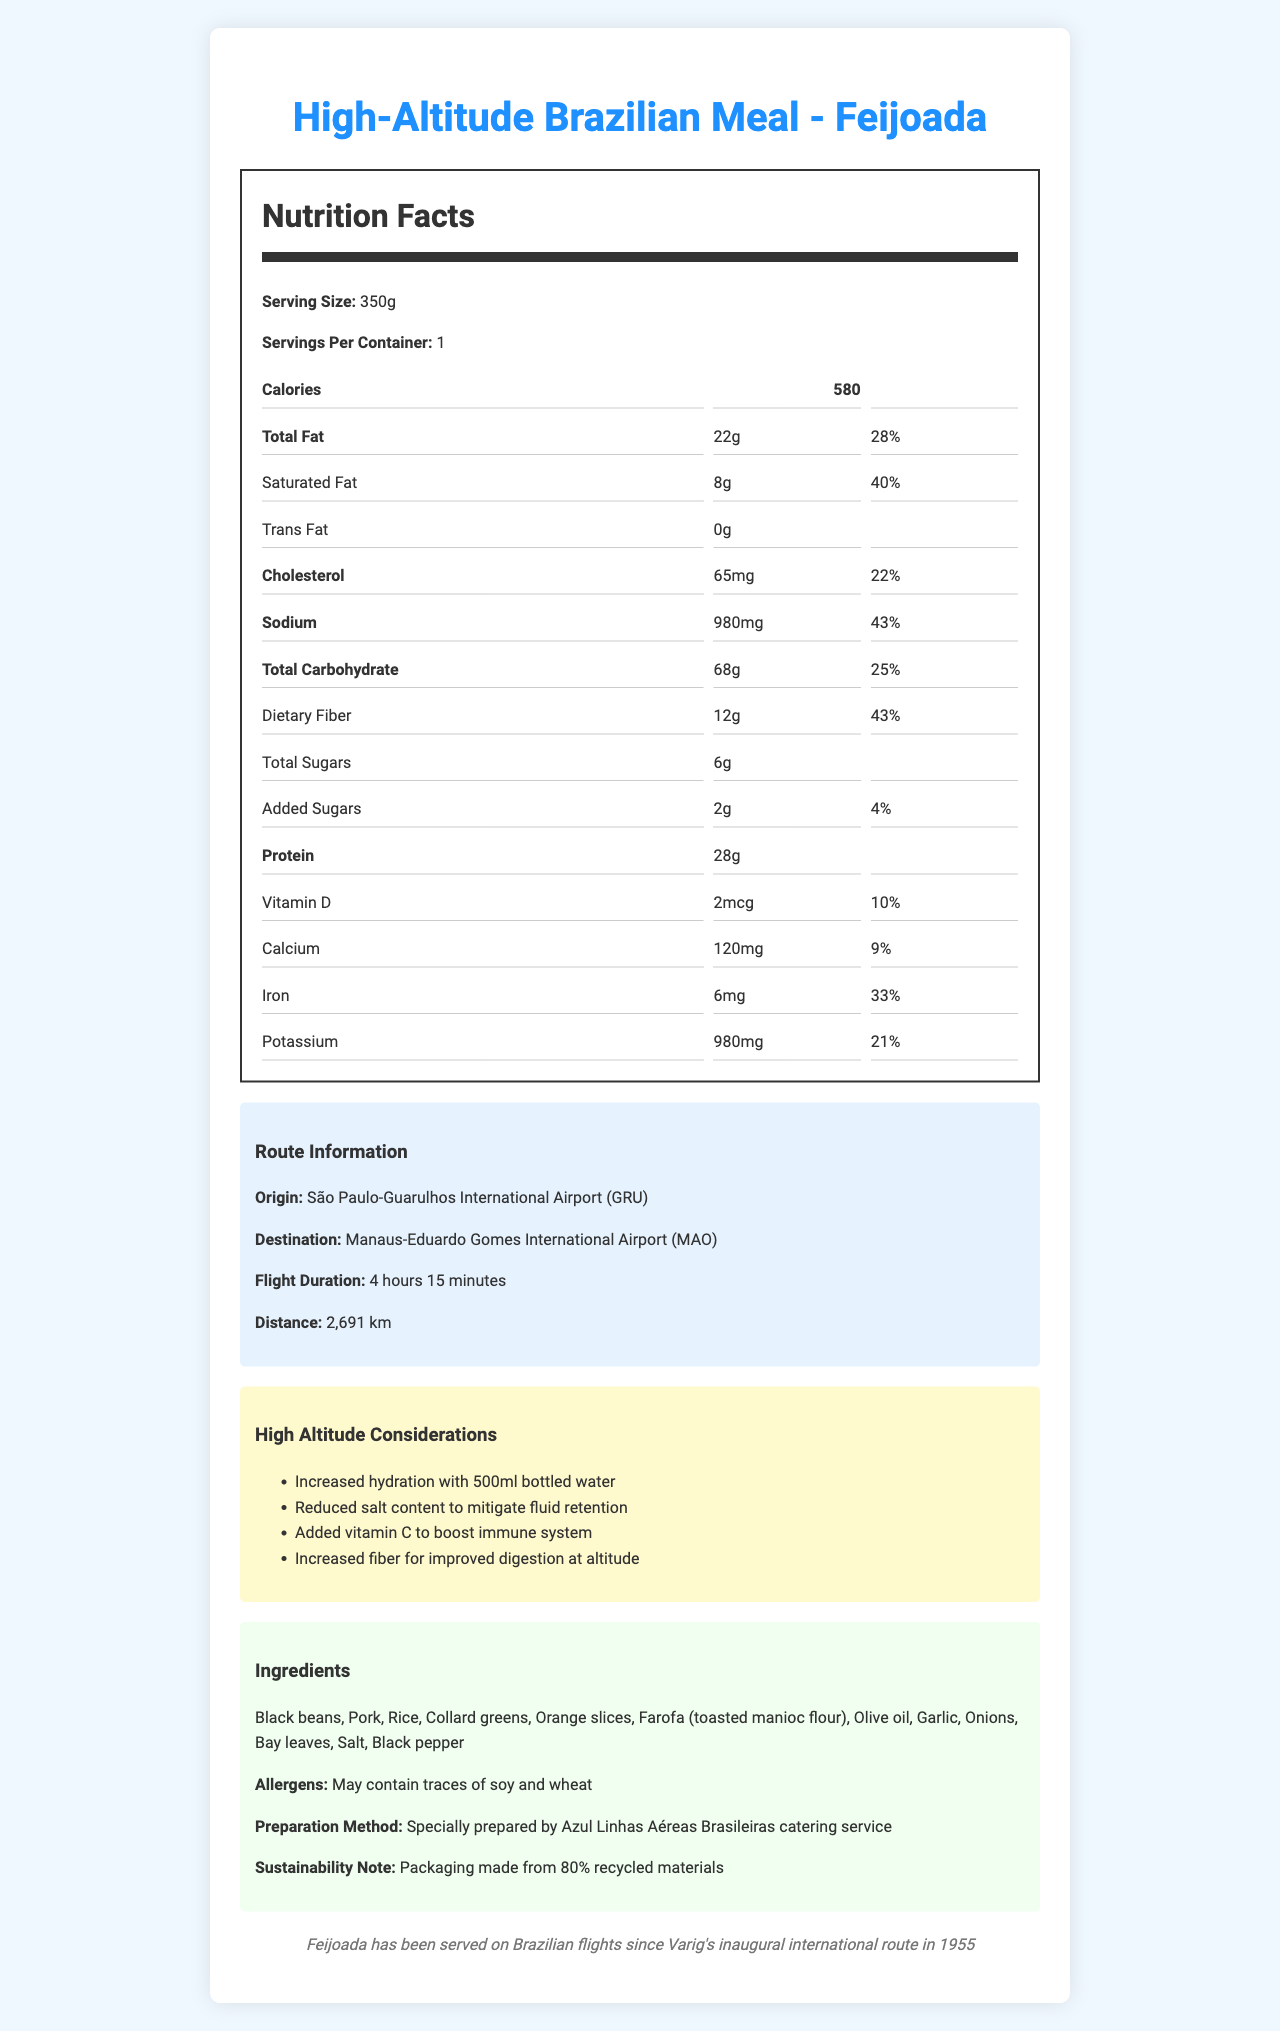what is the serving size of the High-Altitude Brazilian Meal? The serving size is clearly mentioned as 350g in the document.
Answer: 350g how many calories are there per serving of the meal? The document states that each serving contains 580 calories.
Answer: 580 how much dietary fiber is in one serving? The document indicates that there is 12g of dietary fiber per serving.
Answer: 12g how many grams of protein does this meal provide? The document specifies that each serving contains 28g of protein.
Answer: 28g what is the daily value percentage for total carbohydrates? According to the document, the daily value percentage for total carbohydrates is 25%.
Answer: 25% what is the sodium content in milligrams? The sodium content is listed as 980mg in the document.
Answer: 980mg how many servings per container are there? The document specifies that there is 1 serving per container.
Answer: 1 what is the recommended solution to mitigate fluid retention at high altitude? A. Increase fiber B. Reduced salt content C. Added Vitamin C The document lists reduced salt content to mitigate fluid retention among the high altitude considerations.
Answer: B what ingredient is not listed in the meal? A. Black beans B. Chicken C. Collard greens D. Rice Chicken is not listed as an ingredient in the document. The ingredients include black beans, collard greens, and rice.
Answer: B how many added sugars are in the meal? The document states that there are 2g of added sugars in the meal.
Answer: 2g was Feijoada served on Brazilian flights prior to 1955? Yes/No The document mentions that Feijoada has been served on Brazilian flights since 1955, not prior to that.
Answer: No what are some of the high-altitude considerations mentioned? The document lists increased hydration, reduced salt content, added vitamin C, and increased fiber as high-altitude considerations.
Answer: Increased hydration, reduced salt content, added vitamin C, increased fiber is there a sustainability note provided? Describe it. The document mentions that the packaging is made from 80% recycled materials as part of the sustainability note.
Answer: Yes which airport does the route originate from? A. São Paulo-Congonhas B. São Paulo-Guarulhos C. Manaus-Eduardo Gomes D. Rio de Janeiro-Galeão The route originates from São Paulo-Guarulhos International Airport (GRU).
Answer: B how long is the flight duration from São Paulo to Manaus? The document states that the flight duration is 4 hours and 15 minutes.
Answer: 4 hours 15 minutes what are the potential allergens in the meal? The document indicates that the meal may contain traces of soy and wheat.
Answer: Traces of soy and wheat describe the entire document. The document is comprehensive, covering nutrition facts and details relevant to high-altitude travel, route information, and historical context for the in-flight meal.
Answer: The document provides detailed nutrition facts for an in-flight meal, "High-Altitude Brazilian Meal - Feijoada," served on Brazil's longest domestic route from São Paulo-Guarulhos to Manaus-Eduardo Gomes. It includes nutritional content, high-altitude dietary considerations, route information, ingredients, allergens, preparation methods, and historical context. It also mentions sustainability considerations for the meal's packaging. what's the origin of "Feijoada" in relation to Brazilian flights? The document mentions that Feijoada has been served on Brazilian flights since Varig's inaugural international route in 1955.
Answer: 1955 how much added vitamin D is in the meal? The document states that there are 2mcg of vitamin D added to the meal.
Answer: 2mcg what year did Azul Linhas Aéreas Brasileiras start preparing this meal? The document does not contain information about the year when Azul Linhas Aéreas Brasileiras started preparing this meal.
Answer: I don't know 